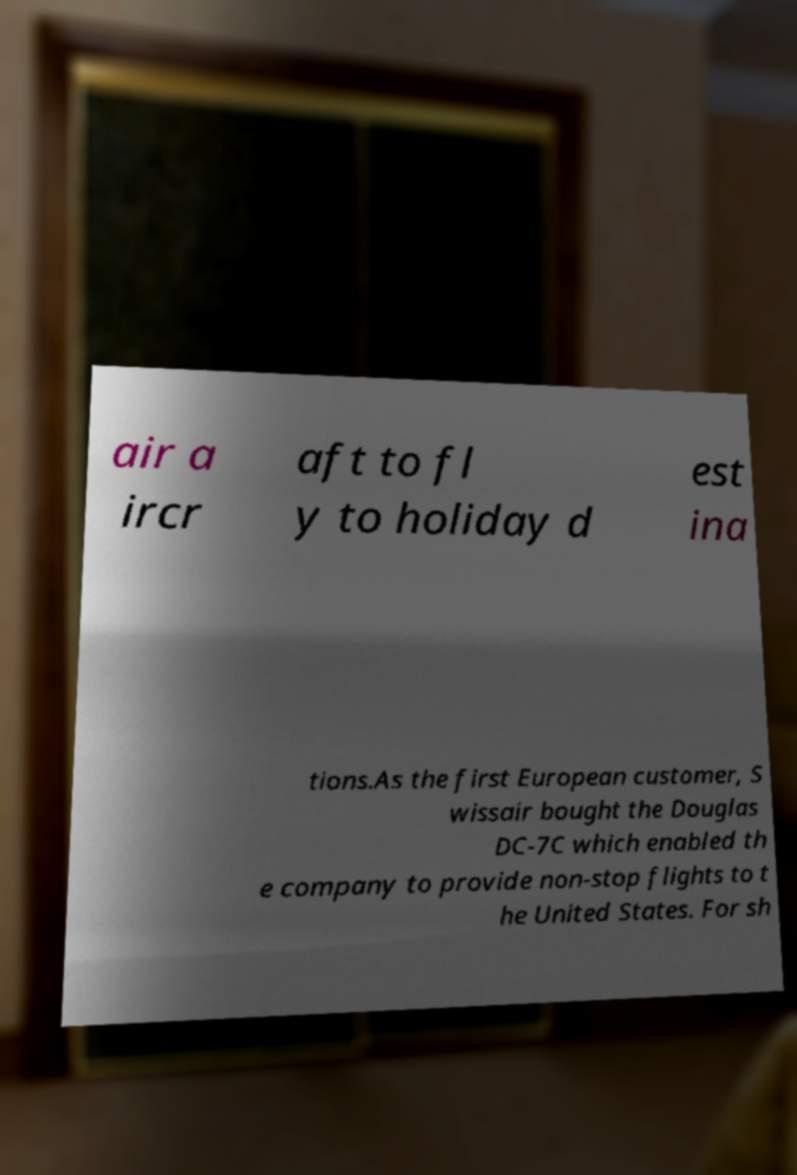Can you read and provide the text displayed in the image?This photo seems to have some interesting text. Can you extract and type it out for me? air a ircr aft to fl y to holiday d est ina tions.As the first European customer, S wissair bought the Douglas DC-7C which enabled th e company to provide non-stop flights to t he United States. For sh 